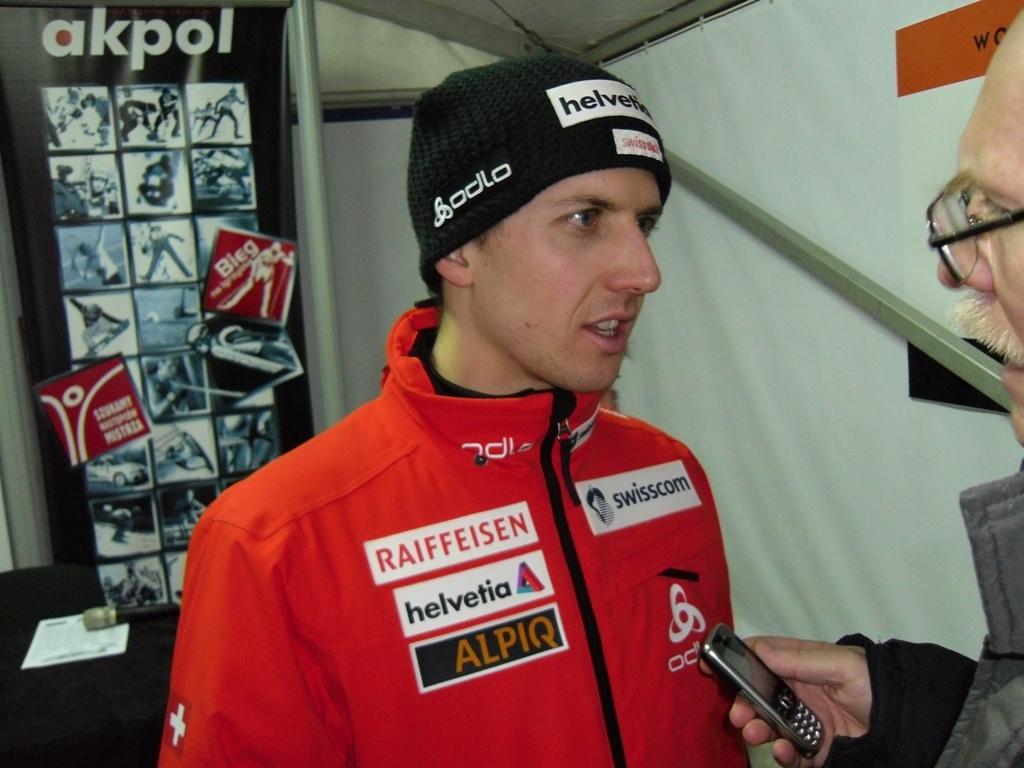What booth is the guy standing in front of?
Your response must be concise. Akpol. Who is sponsoring him?
Your answer should be very brief. Alpiq. 